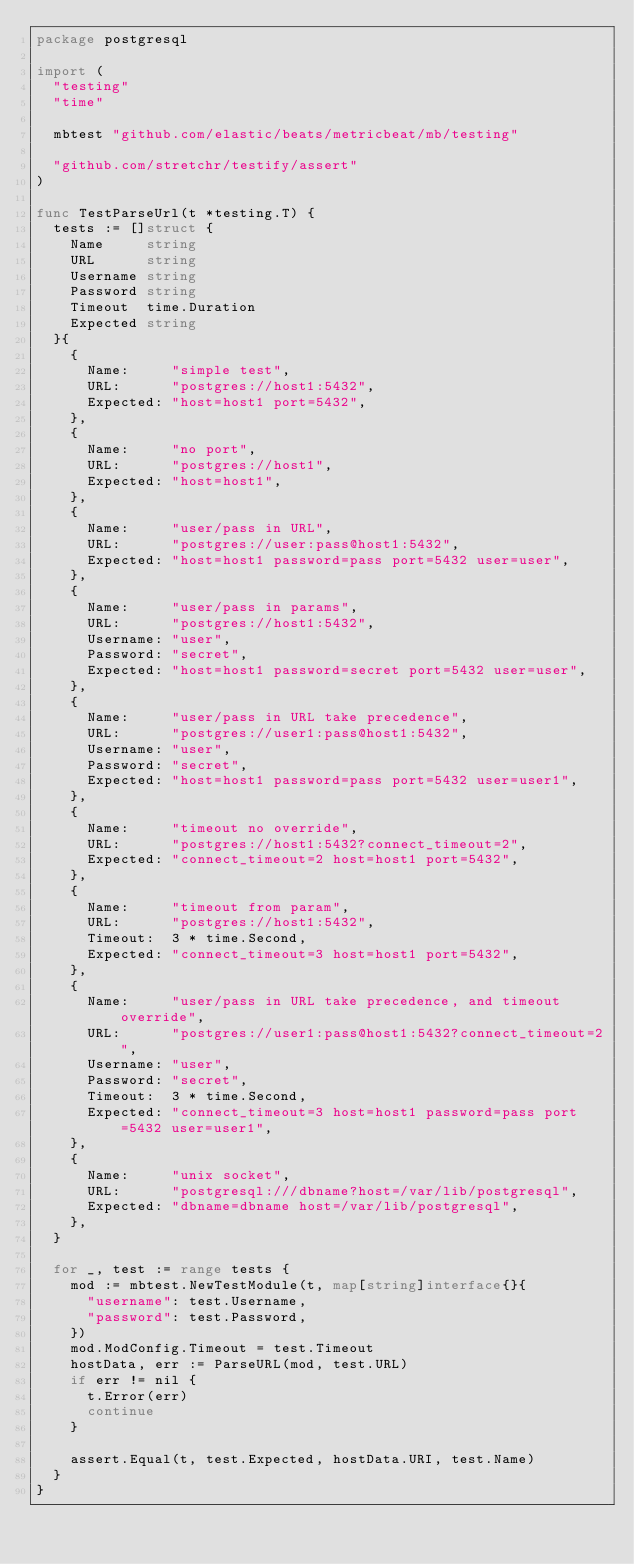Convert code to text. <code><loc_0><loc_0><loc_500><loc_500><_Go_>package postgresql

import (
	"testing"
	"time"

	mbtest "github.com/elastic/beats/metricbeat/mb/testing"

	"github.com/stretchr/testify/assert"
)

func TestParseUrl(t *testing.T) {
	tests := []struct {
		Name     string
		URL      string
		Username string
		Password string
		Timeout  time.Duration
		Expected string
	}{
		{
			Name:     "simple test",
			URL:      "postgres://host1:5432",
			Expected: "host=host1 port=5432",
		},
		{
			Name:     "no port",
			URL:      "postgres://host1",
			Expected: "host=host1",
		},
		{
			Name:     "user/pass in URL",
			URL:      "postgres://user:pass@host1:5432",
			Expected: "host=host1 password=pass port=5432 user=user",
		},
		{
			Name:     "user/pass in params",
			URL:      "postgres://host1:5432",
			Username: "user",
			Password: "secret",
			Expected: "host=host1 password=secret port=5432 user=user",
		},
		{
			Name:     "user/pass in URL take precedence",
			URL:      "postgres://user1:pass@host1:5432",
			Username: "user",
			Password: "secret",
			Expected: "host=host1 password=pass port=5432 user=user1",
		},
		{
			Name:     "timeout no override",
			URL:      "postgres://host1:5432?connect_timeout=2",
			Expected: "connect_timeout=2 host=host1 port=5432",
		},
		{
			Name:     "timeout from param",
			URL:      "postgres://host1:5432",
			Timeout:  3 * time.Second,
			Expected: "connect_timeout=3 host=host1 port=5432",
		},
		{
			Name:     "user/pass in URL take precedence, and timeout override",
			URL:      "postgres://user1:pass@host1:5432?connect_timeout=2",
			Username: "user",
			Password: "secret",
			Timeout:  3 * time.Second,
			Expected: "connect_timeout=3 host=host1 password=pass port=5432 user=user1",
		},
		{
			Name:     "unix socket",
			URL:      "postgresql:///dbname?host=/var/lib/postgresql",
			Expected: "dbname=dbname host=/var/lib/postgresql",
		},
	}

	for _, test := range tests {
		mod := mbtest.NewTestModule(t, map[string]interface{}{
			"username": test.Username,
			"password": test.Password,
		})
		mod.ModConfig.Timeout = test.Timeout
		hostData, err := ParseURL(mod, test.URL)
		if err != nil {
			t.Error(err)
			continue
		}

		assert.Equal(t, test.Expected, hostData.URI, test.Name)
	}
}
</code> 